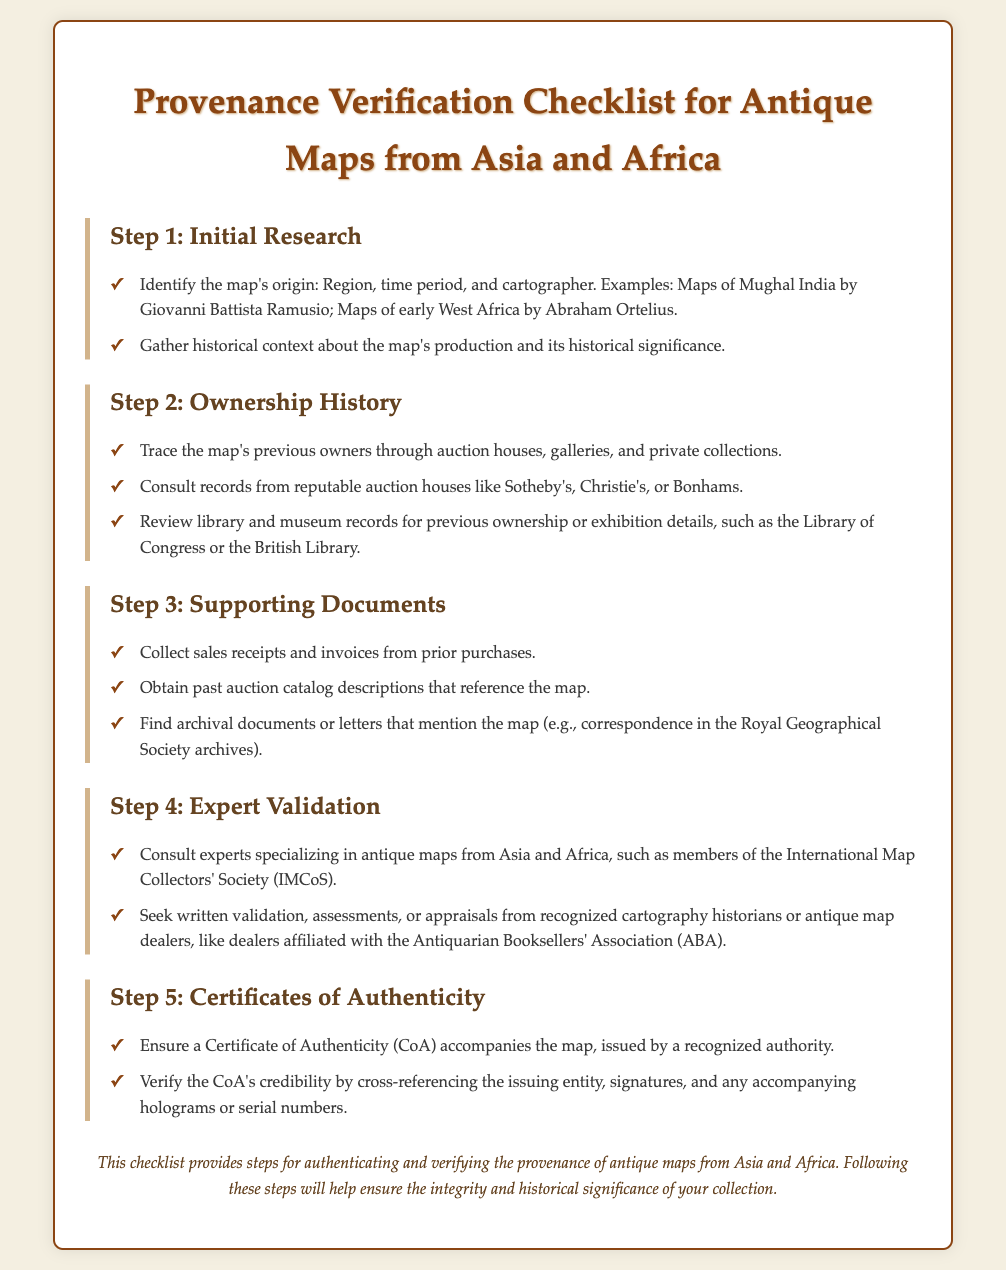What is the first step in the checklist? The first step in the checklist is to conduct initial research regarding the map's origin and historical context.
Answer: Initial Research Which organization specializes in antique maps? The document mentions the International Map Collectors' Society as an organization focused on antique maps.
Answer: International Map Collectors' Society What should accompany the map as proof of authenticity? A Certificate of Authenticity (CoA) should accompany the map as proof of its authenticity.
Answer: Certificate of Authenticity How many steps are outlined in the checklist? The document outlines a total of five steps for provenance verification.
Answer: Five steps What type of records should be consulted for ownership history? Records from reputable auction houses, galleries, and private collections should be consulted for ownership history.
Answer: Reputable auction houses Who should validate the map according to the checklist? Experts specializing in antique maps should validate the map, such as members of the IMCoS.
Answer: Experts specializing in antique maps What should be verified about the Certificate of Authenticity? The credibility of the Certificate of Authenticity should be verified by cross-referencing the issuing entity and signatures.
Answer: Credibility verification 